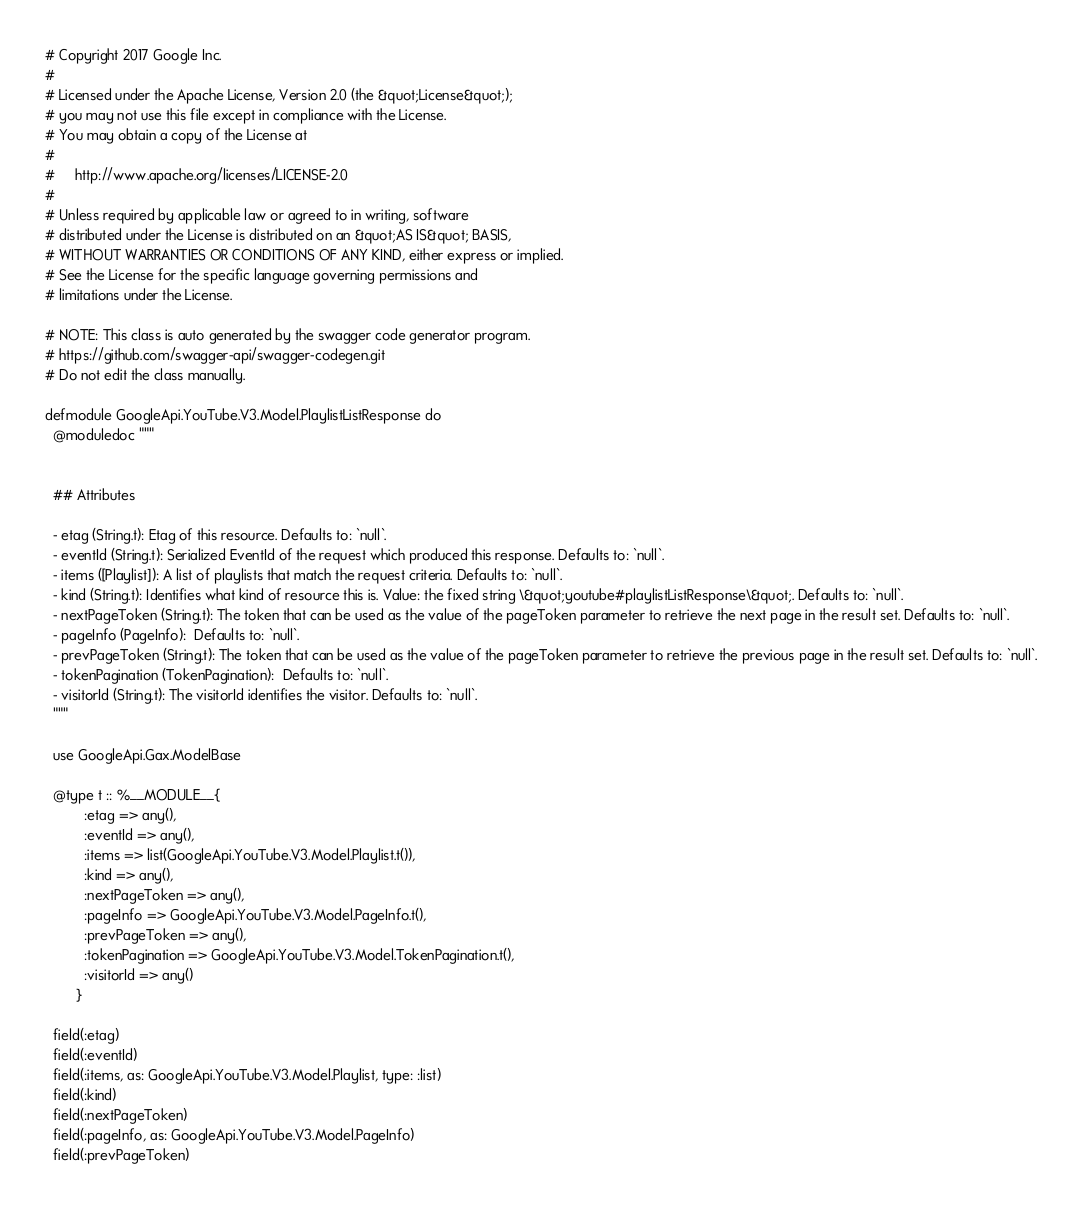Convert code to text. <code><loc_0><loc_0><loc_500><loc_500><_Elixir_># Copyright 2017 Google Inc.
#
# Licensed under the Apache License, Version 2.0 (the &quot;License&quot;);
# you may not use this file except in compliance with the License.
# You may obtain a copy of the License at
#
#     http://www.apache.org/licenses/LICENSE-2.0
#
# Unless required by applicable law or agreed to in writing, software
# distributed under the License is distributed on an &quot;AS IS&quot; BASIS,
# WITHOUT WARRANTIES OR CONDITIONS OF ANY KIND, either express or implied.
# See the License for the specific language governing permissions and
# limitations under the License.

# NOTE: This class is auto generated by the swagger code generator program.
# https://github.com/swagger-api/swagger-codegen.git
# Do not edit the class manually.

defmodule GoogleApi.YouTube.V3.Model.PlaylistListResponse do
  @moduledoc """


  ## Attributes

  - etag (String.t): Etag of this resource. Defaults to: `null`.
  - eventId (String.t): Serialized EventId of the request which produced this response. Defaults to: `null`.
  - items ([Playlist]): A list of playlists that match the request criteria. Defaults to: `null`.
  - kind (String.t): Identifies what kind of resource this is. Value: the fixed string \&quot;youtube#playlistListResponse\&quot;. Defaults to: `null`.
  - nextPageToken (String.t): The token that can be used as the value of the pageToken parameter to retrieve the next page in the result set. Defaults to: `null`.
  - pageInfo (PageInfo):  Defaults to: `null`.
  - prevPageToken (String.t): The token that can be used as the value of the pageToken parameter to retrieve the previous page in the result set. Defaults to: `null`.
  - tokenPagination (TokenPagination):  Defaults to: `null`.
  - visitorId (String.t): The visitorId identifies the visitor. Defaults to: `null`.
  """

  use GoogleApi.Gax.ModelBase

  @type t :: %__MODULE__{
          :etag => any(),
          :eventId => any(),
          :items => list(GoogleApi.YouTube.V3.Model.Playlist.t()),
          :kind => any(),
          :nextPageToken => any(),
          :pageInfo => GoogleApi.YouTube.V3.Model.PageInfo.t(),
          :prevPageToken => any(),
          :tokenPagination => GoogleApi.YouTube.V3.Model.TokenPagination.t(),
          :visitorId => any()
        }

  field(:etag)
  field(:eventId)
  field(:items, as: GoogleApi.YouTube.V3.Model.Playlist, type: :list)
  field(:kind)
  field(:nextPageToken)
  field(:pageInfo, as: GoogleApi.YouTube.V3.Model.PageInfo)
  field(:prevPageToken)</code> 